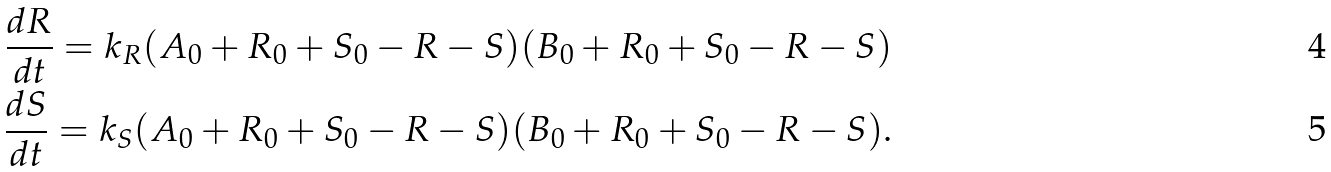<formula> <loc_0><loc_0><loc_500><loc_500>\frac { d R } { d t } = k _ { R } ( A _ { 0 } + R _ { 0 } + S _ { 0 } - R - S ) ( B _ { 0 } + R _ { 0 } + S _ { 0 } - R - S ) \\ \frac { d S } { d t } = k _ { S } ( A _ { 0 } + R _ { 0 } + S _ { 0 } - R - S ) ( B _ { 0 } + R _ { 0 } + S _ { 0 } - R - S ) .</formula> 